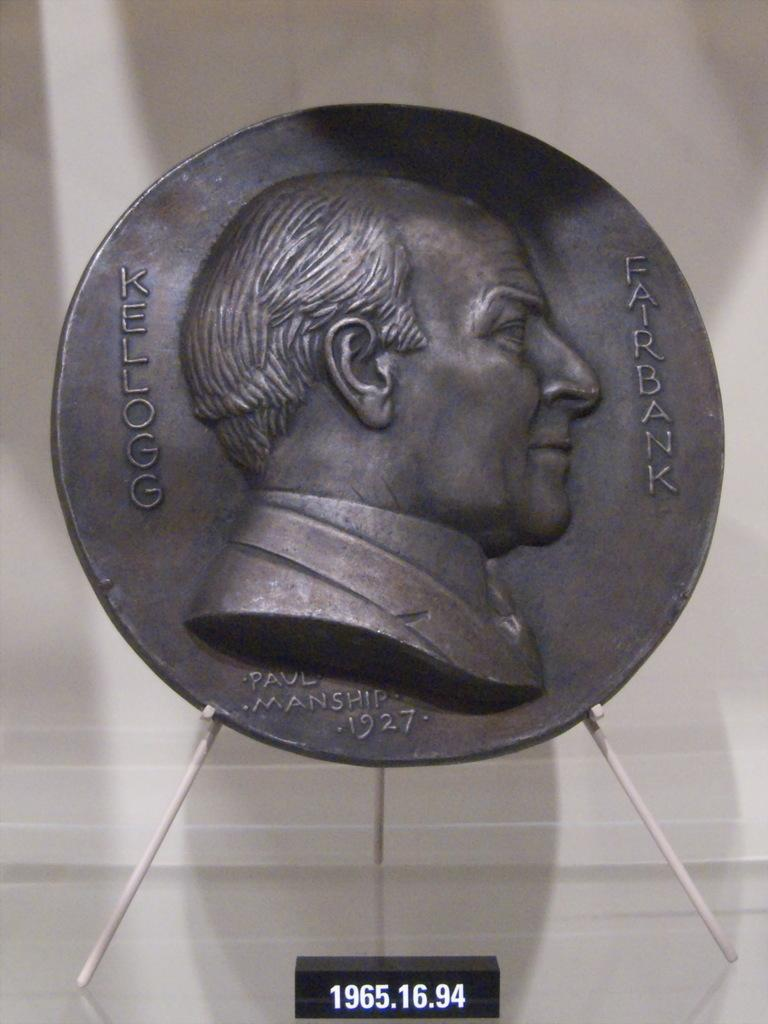<image>
Render a clear and concise summary of the photo. A statue of a man's head with the words kellogg and Fairbank on it. 